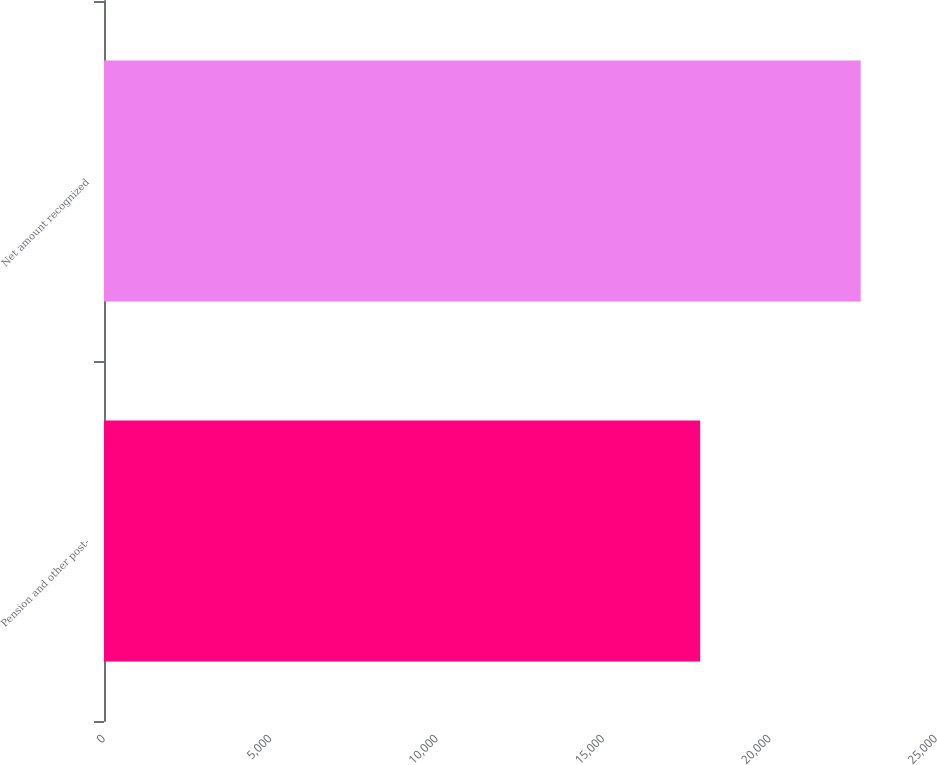Convert chart to OTSL. <chart><loc_0><loc_0><loc_500><loc_500><bar_chart><fcel>Pension and other post-<fcel>Net amount recognized<nl><fcel>17914<fcel>22737<nl></chart> 